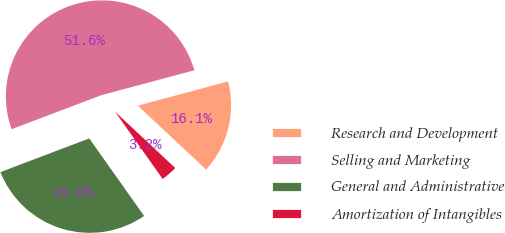Convert chart. <chart><loc_0><loc_0><loc_500><loc_500><pie_chart><fcel>Research and Development<fcel>Selling and Marketing<fcel>General and Administrative<fcel>Amortization of Intangibles<nl><fcel>16.13%<fcel>51.61%<fcel>29.03%<fcel>3.23%<nl></chart> 